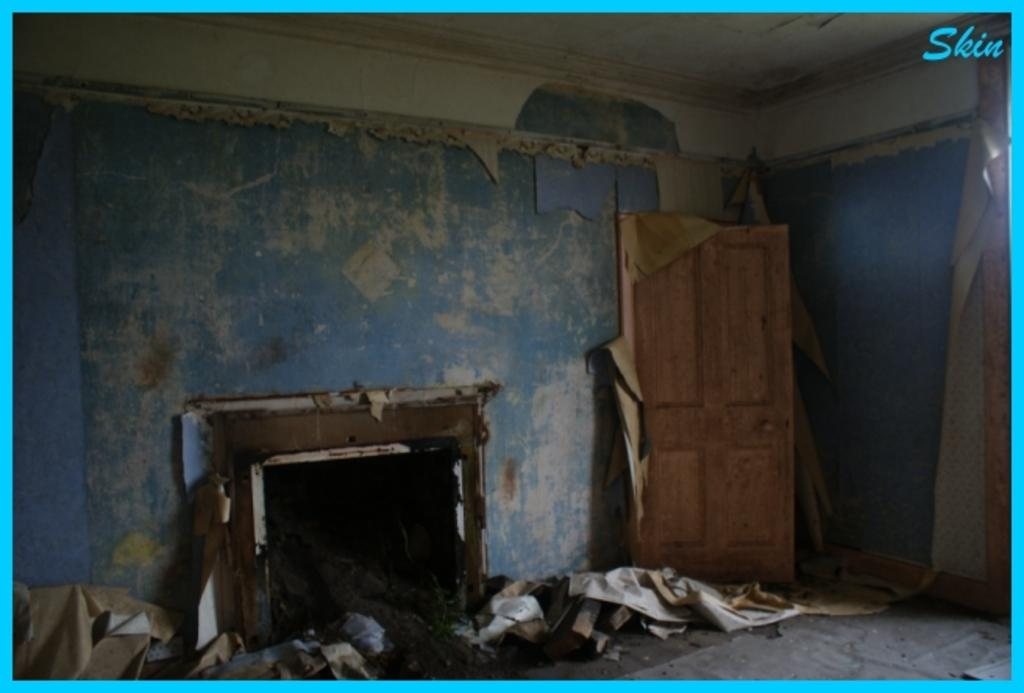What is a prominent feature in the image? There is a door in the image. What can be found on the floor in the image? There are objects on the floor in the image. What type of structures can be seen in the background of the image? The background of the image includes walls and a ceiling. How does the door roll in the image? The door does not roll in the image; it is stationary and likely used for entering or exiting a room. 